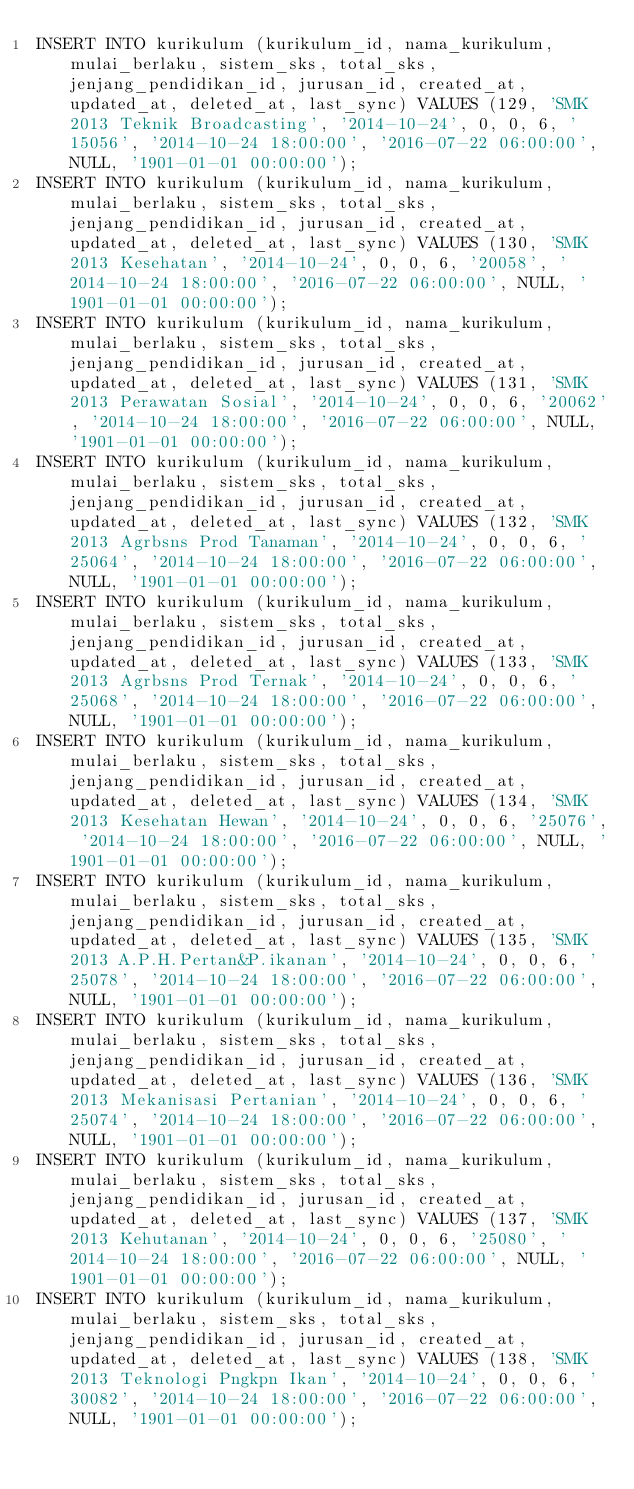<code> <loc_0><loc_0><loc_500><loc_500><_SQL_>INSERT INTO kurikulum (kurikulum_id, nama_kurikulum, mulai_berlaku, sistem_sks, total_sks, jenjang_pendidikan_id, jurusan_id, created_at, updated_at, deleted_at, last_sync) VALUES (129, 'SMK 2013 Teknik Broadcasting', '2014-10-24', 0, 0, 6, '15056', '2014-10-24 18:00:00', '2016-07-22 06:00:00', NULL, '1901-01-01 00:00:00');
INSERT INTO kurikulum (kurikulum_id, nama_kurikulum, mulai_berlaku, sistem_sks, total_sks, jenjang_pendidikan_id, jurusan_id, created_at, updated_at, deleted_at, last_sync) VALUES (130, 'SMK 2013 Kesehatan', '2014-10-24', 0, 0, 6, '20058', '2014-10-24 18:00:00', '2016-07-22 06:00:00', NULL, '1901-01-01 00:00:00');
INSERT INTO kurikulum (kurikulum_id, nama_kurikulum, mulai_berlaku, sistem_sks, total_sks, jenjang_pendidikan_id, jurusan_id, created_at, updated_at, deleted_at, last_sync) VALUES (131, 'SMK 2013 Perawatan Sosial', '2014-10-24', 0, 0, 6, '20062', '2014-10-24 18:00:00', '2016-07-22 06:00:00', NULL, '1901-01-01 00:00:00');
INSERT INTO kurikulum (kurikulum_id, nama_kurikulum, mulai_berlaku, sistem_sks, total_sks, jenjang_pendidikan_id, jurusan_id, created_at, updated_at, deleted_at, last_sync) VALUES (132, 'SMK 2013 Agrbsns Prod Tanaman', '2014-10-24', 0, 0, 6, '25064', '2014-10-24 18:00:00', '2016-07-22 06:00:00', NULL, '1901-01-01 00:00:00');
INSERT INTO kurikulum (kurikulum_id, nama_kurikulum, mulai_berlaku, sistem_sks, total_sks, jenjang_pendidikan_id, jurusan_id, created_at, updated_at, deleted_at, last_sync) VALUES (133, 'SMK 2013 Agrbsns Prod Ternak', '2014-10-24', 0, 0, 6, '25068', '2014-10-24 18:00:00', '2016-07-22 06:00:00', NULL, '1901-01-01 00:00:00');
INSERT INTO kurikulum (kurikulum_id, nama_kurikulum, mulai_berlaku, sistem_sks, total_sks, jenjang_pendidikan_id, jurusan_id, created_at, updated_at, deleted_at, last_sync) VALUES (134, 'SMK 2013 Kesehatan Hewan', '2014-10-24', 0, 0, 6, '25076', '2014-10-24 18:00:00', '2016-07-22 06:00:00', NULL, '1901-01-01 00:00:00');
INSERT INTO kurikulum (kurikulum_id, nama_kurikulum, mulai_berlaku, sistem_sks, total_sks, jenjang_pendidikan_id, jurusan_id, created_at, updated_at, deleted_at, last_sync) VALUES (135, 'SMK 2013 A.P.H.Pertan&P.ikanan', '2014-10-24', 0, 0, 6, '25078', '2014-10-24 18:00:00', '2016-07-22 06:00:00', NULL, '1901-01-01 00:00:00');
INSERT INTO kurikulum (kurikulum_id, nama_kurikulum, mulai_berlaku, sistem_sks, total_sks, jenjang_pendidikan_id, jurusan_id, created_at, updated_at, deleted_at, last_sync) VALUES (136, 'SMK 2013 Mekanisasi Pertanian', '2014-10-24', 0, 0, 6, '25074', '2014-10-24 18:00:00', '2016-07-22 06:00:00', NULL, '1901-01-01 00:00:00');
INSERT INTO kurikulum (kurikulum_id, nama_kurikulum, mulai_berlaku, sistem_sks, total_sks, jenjang_pendidikan_id, jurusan_id, created_at, updated_at, deleted_at, last_sync) VALUES (137, 'SMK 2013 Kehutanan', '2014-10-24', 0, 0, 6, '25080', '2014-10-24 18:00:00', '2016-07-22 06:00:00', NULL, '1901-01-01 00:00:00');
INSERT INTO kurikulum (kurikulum_id, nama_kurikulum, mulai_berlaku, sistem_sks, total_sks, jenjang_pendidikan_id, jurusan_id, created_at, updated_at, deleted_at, last_sync) VALUES (138, 'SMK 2013 Teknologi Pngkpn Ikan', '2014-10-24', 0, 0, 6, '30082', '2014-10-24 18:00:00', '2016-07-22 06:00:00', NULL, '1901-01-01 00:00:00');</code> 